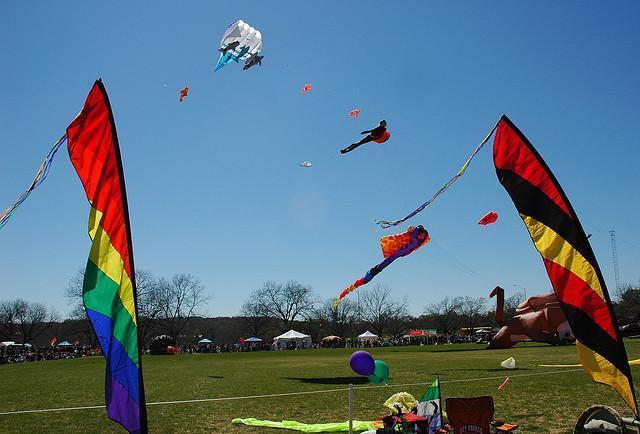How many kites are there?
Give a very brief answer. 2. 